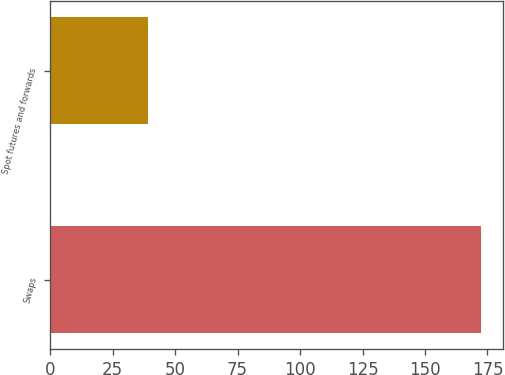<chart> <loc_0><loc_0><loc_500><loc_500><bar_chart><fcel>Swaps<fcel>Spot futures and forwards<nl><fcel>172.5<fcel>39.1<nl></chart> 